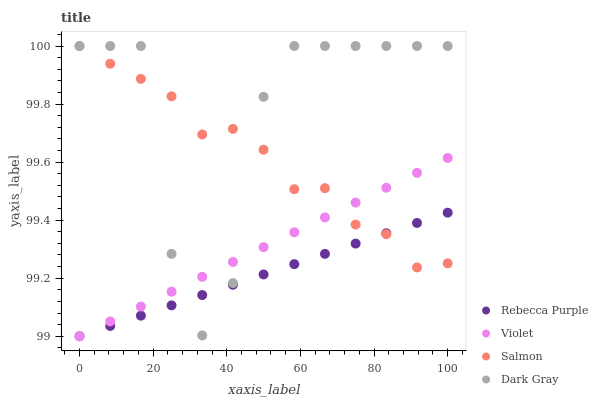Does Rebecca Purple have the minimum area under the curve?
Answer yes or no. Yes. Does Dark Gray have the maximum area under the curve?
Answer yes or no. Yes. Does Salmon have the minimum area under the curve?
Answer yes or no. No. Does Salmon have the maximum area under the curve?
Answer yes or no. No. Is Violet the smoothest?
Answer yes or no. Yes. Is Dark Gray the roughest?
Answer yes or no. Yes. Is Salmon the smoothest?
Answer yes or no. No. Is Salmon the roughest?
Answer yes or no. No. Does Rebecca Purple have the lowest value?
Answer yes or no. Yes. Does Salmon have the lowest value?
Answer yes or no. No. Does Salmon have the highest value?
Answer yes or no. Yes. Does Rebecca Purple have the highest value?
Answer yes or no. No. Does Violet intersect Salmon?
Answer yes or no. Yes. Is Violet less than Salmon?
Answer yes or no. No. Is Violet greater than Salmon?
Answer yes or no. No. 